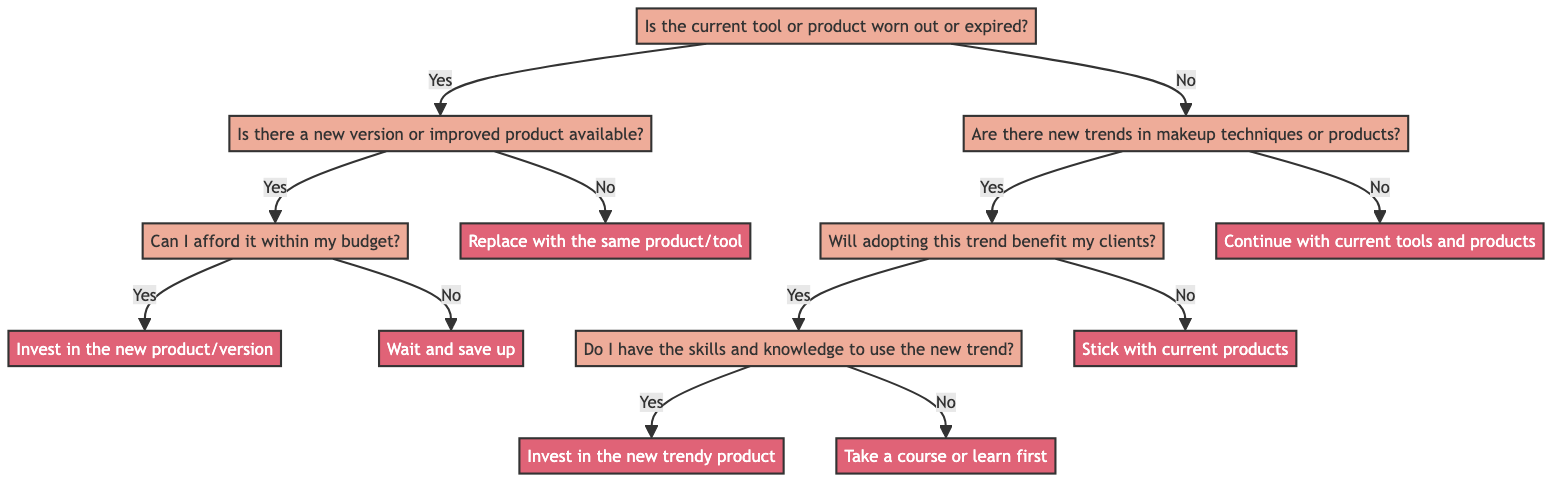Is the first question in the decision tree about product condition? The first question in the decision tree is "Is the current tool or product worn out or expired?" which evaluates the condition of the product before considering purchases.
Answer: Yes What happens if the answer to the first question is "No"? If the answer to the first question is "No," the flowchart directs to the second question, "Are there new trends in makeup techniques or products?" This shows that if the current tool is not worn out, the focus shifts to trends.
Answer: Proceed to trends How many actions are presented in the decision tree? The diagram presents five actions: "Invest in the new product/version," "Wait and save up," "Replace with the same product/tool," "Stick with current products," and "Take a course or learn first," compiling all the suggested actions.
Answer: Five actions If I cannot afford a new version, what should I do? If the answer to "Can I afford it within my budget?" is "No," the action states "Wait and save up," suggesting a pause before investing.
Answer: Wait and save up What is the next step if adopting a new trend is beneficial for clients? If "Will adopting this trend benefit my clients?" is answered with "Yes," the next question to answer is "Do I have the skills and knowledge to use the new trend?" which further explores readiness for the new trend.
Answer: Assess skills and knowledge How does the decision tree guide you if there are no new trends? If the second question "Are there new trends in makeup techniques or products?" is answered with "No," the action taken is "Continue with current tools and products," indicating no need for change.
Answer: Continue with current tools What does the decision tree suggest if I lack skills for a new trend? If the answer to "Do I have the skills and knowledge to use the new trend?" is "No," the suggested action is "Take a course or learn first," to improve skills before adopting new trends.
Answer: Take a course or learn first What should I do if the current tool is worn out but no improved version exists? If the answer to "Is there a new version or improved product available?" is "No," the action is to "Replace with the same product/tool," indicating a need to replace the worn-out product without upgrading.
Answer: Replace with the same product/tool 